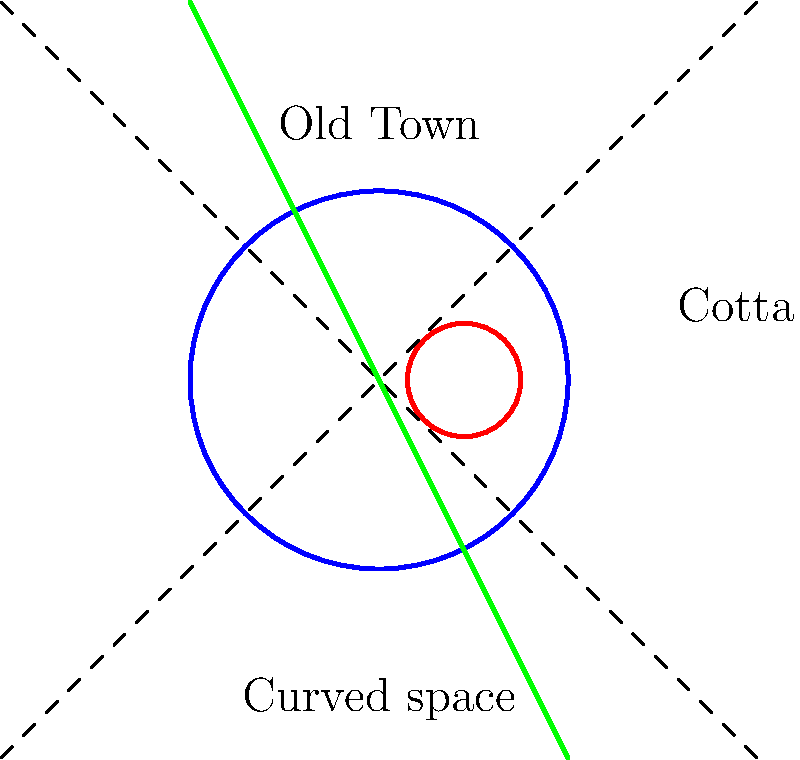In a Non-Euclidean model of Dresden's Old Town, represented by the blue circle, how would the shortest path between the Old Town and the district of Cotta (red circle) be affected by the curvature of space (green curve)? To understand this Non-Euclidean model of Dresden's Old Town, we need to consider the following steps:

1. In Euclidean geometry, the shortest path between two points is a straight line. However, in Non-Euclidean geometry, this is not always the case.

2. The blue circle represents Dresden's Old Town, while the red circle represents the district of Cotta.

3. The green curve represents the curvature of space in this Non-Euclidean model.

4. In Non-Euclidean geometry, the shortest path between two points follows the geodesic, which is the equivalent of a straight line on a curved surface.

5. The curvature of space (green curve) suggests that the space between the Old Town and Cotta is not flat but curved.

6. As a result, the shortest path between the Old Town and Cotta would not be a straight line, but rather a curved path that follows the curvature of space.

7. This curved path would likely be longer than a straight line in Euclidean space but would represent the shortest possible route in this Non-Euclidean model.

8. For a historian of Dresden, this model could provide interesting insights into how the perception of distance and space might have differed in historical times, potentially influencing urban development and the relationship between different districts.
Answer: The shortest path would curve, following the geodesic of the Non-Euclidean space. 